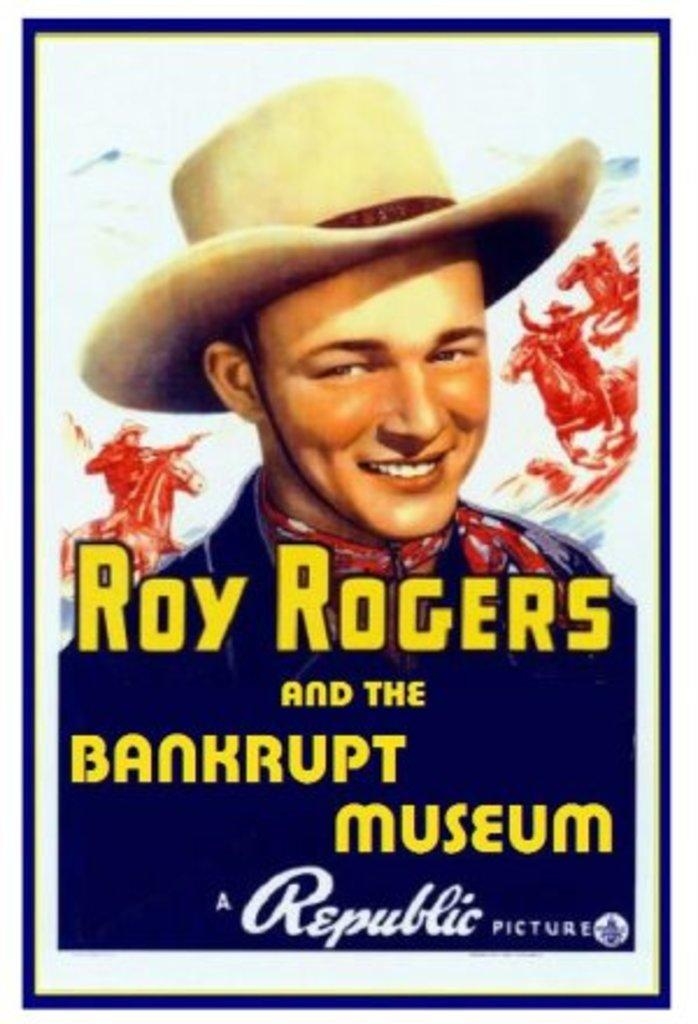<image>
Summarize the visual content of the image. Roy Rodgers and the Bankrupt Museum poster that says: A Republic Picture. 